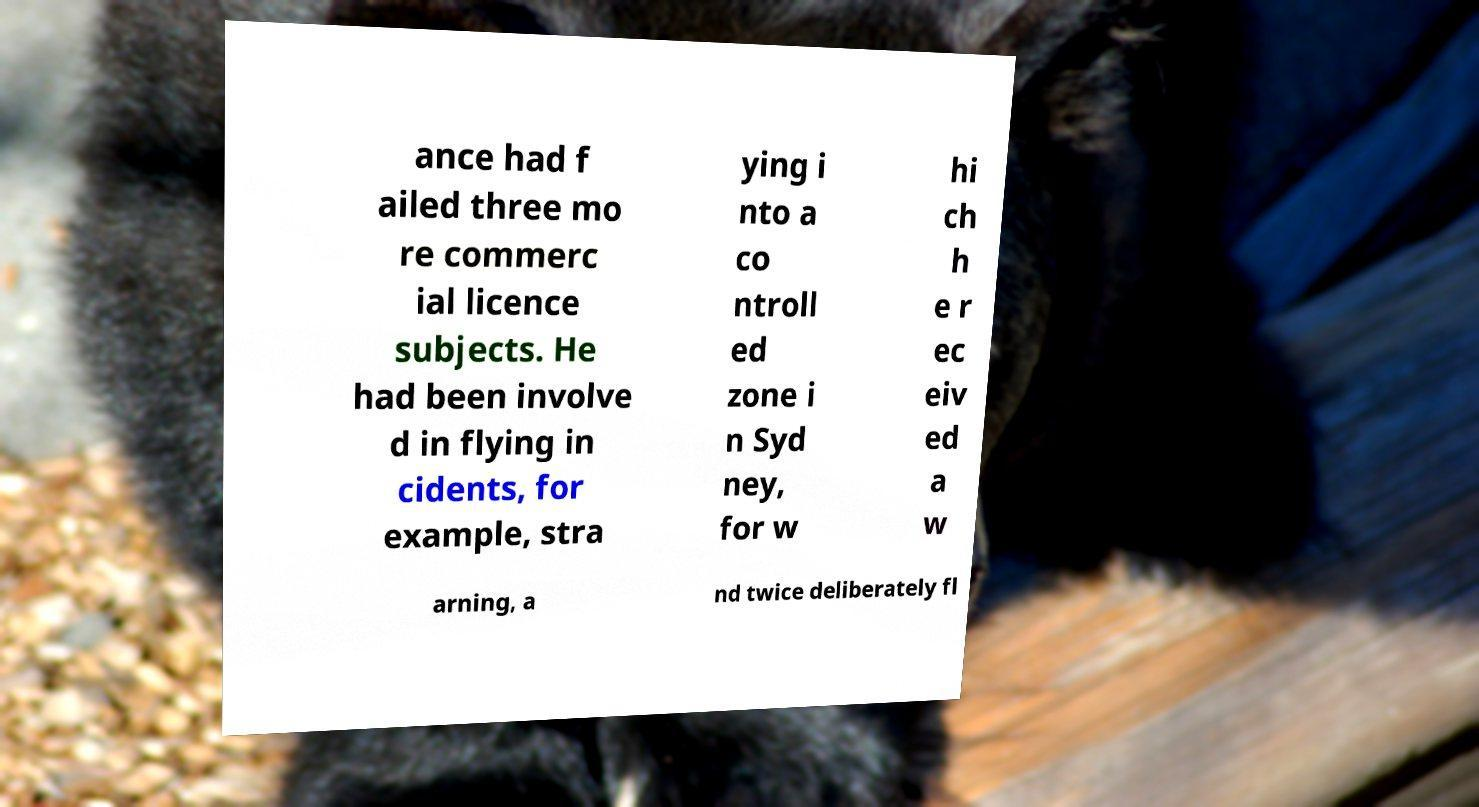Please identify and transcribe the text found in this image. ance had f ailed three mo re commerc ial licence subjects. He had been involve d in flying in cidents, for example, stra ying i nto a co ntroll ed zone i n Syd ney, for w hi ch h e r ec eiv ed a w arning, a nd twice deliberately fl 